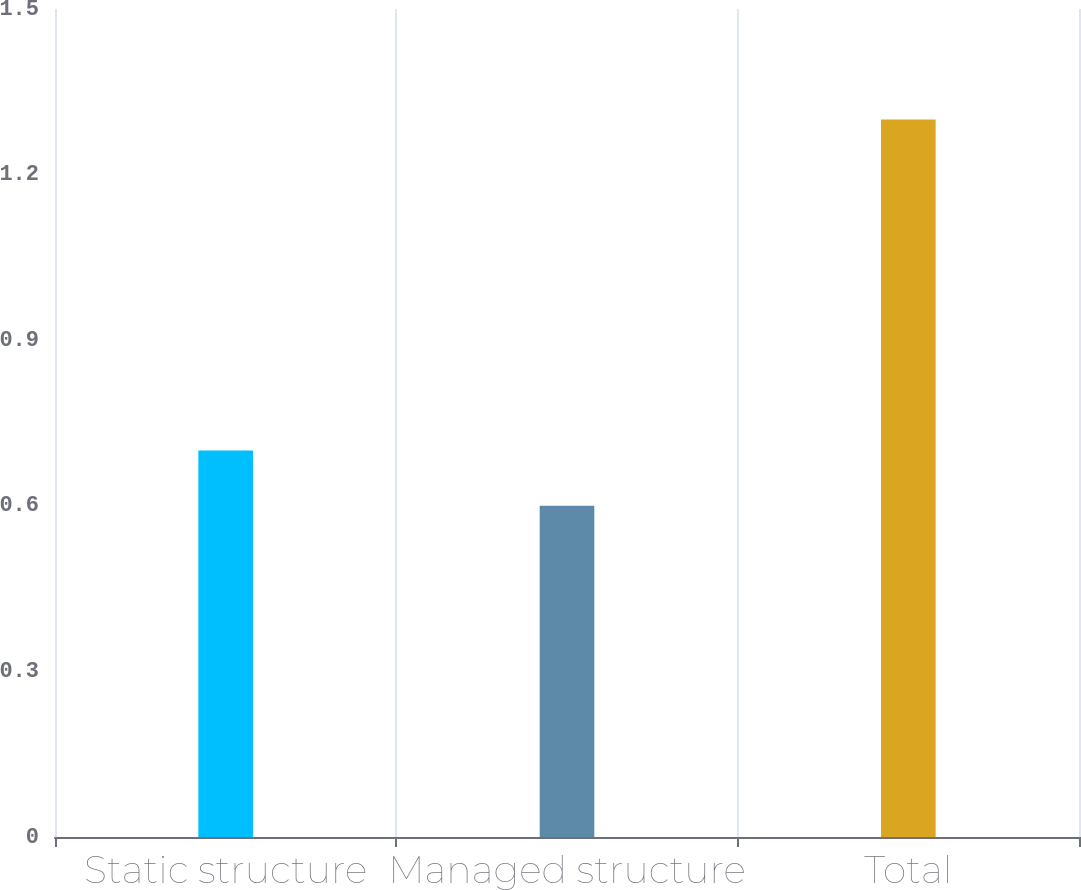Convert chart to OTSL. <chart><loc_0><loc_0><loc_500><loc_500><bar_chart><fcel>Static structure<fcel>Managed structure<fcel>Total<nl><fcel>0.7<fcel>0.6<fcel>1.3<nl></chart> 